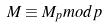<formula> <loc_0><loc_0><loc_500><loc_500>M \equiv M _ { p } m o d p</formula> 